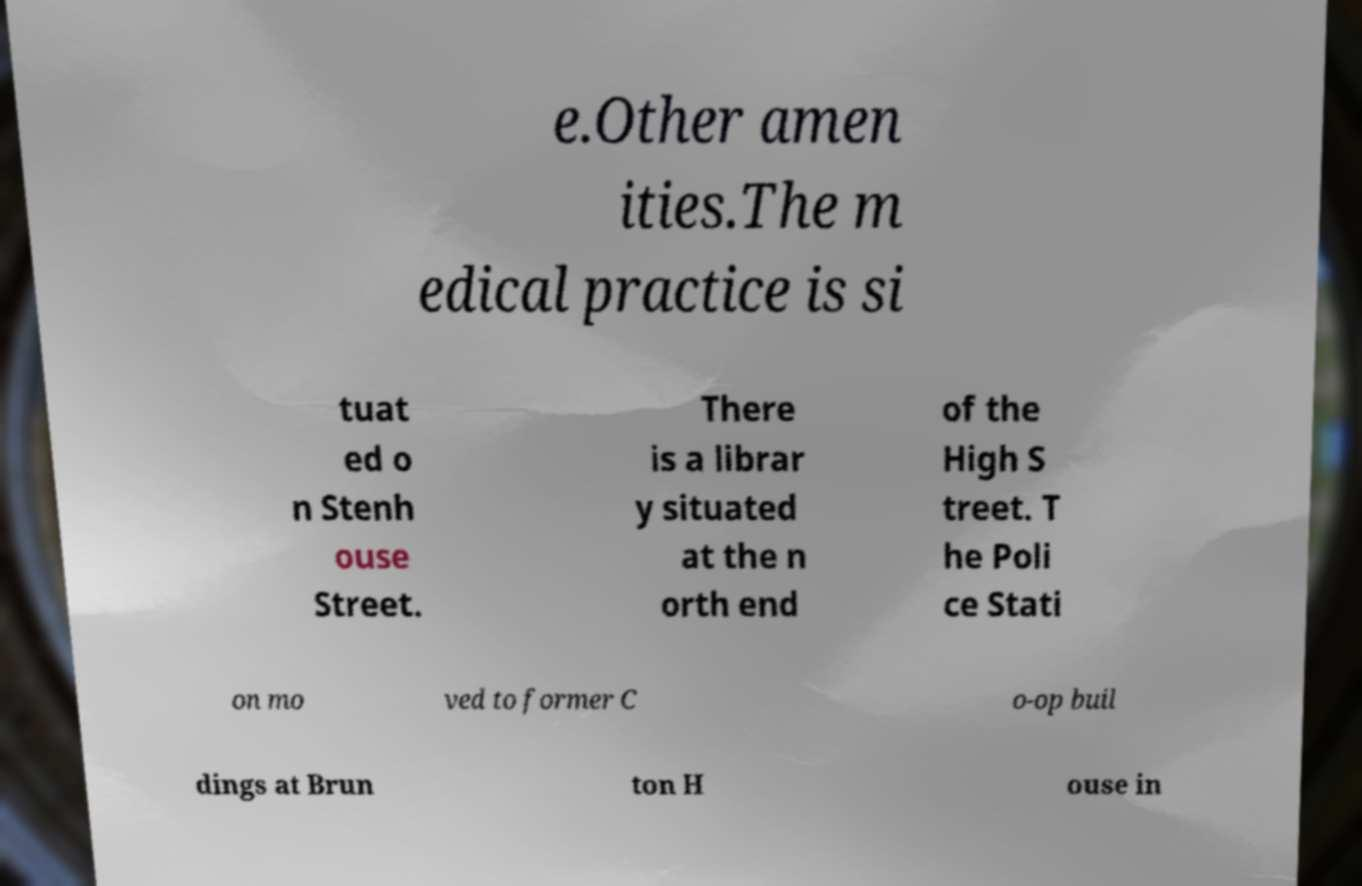What messages or text are displayed in this image? I need them in a readable, typed format. e.Other amen ities.The m edical practice is si tuat ed o n Stenh ouse Street. There is a librar y situated at the n orth end of the High S treet. T he Poli ce Stati on mo ved to former C o-op buil dings at Brun ton H ouse in 